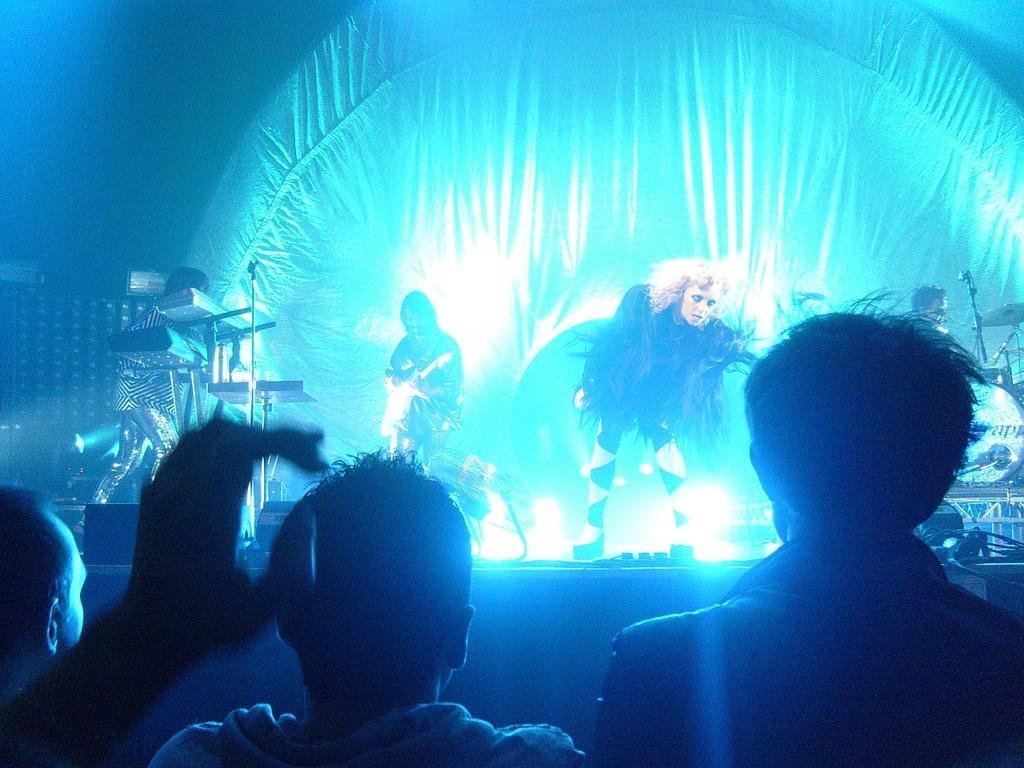Describe this image in one or two sentences. In this image in the front there are persons. In the center there are musicians performing on the stage and there are musical instruments. In the background there is a curtain and there are lights. 